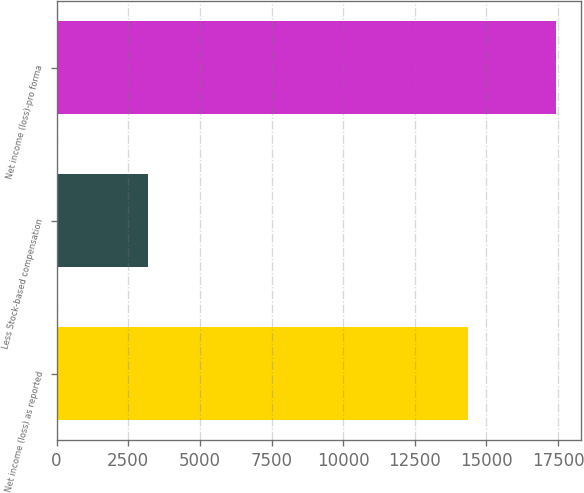<chart> <loc_0><loc_0><loc_500><loc_500><bar_chart><fcel>Net income (loss) as reported<fcel>Less Stock-based compensation<fcel>Net income (loss)-pro forma<nl><fcel>14358<fcel>3194<fcel>17429<nl></chart> 